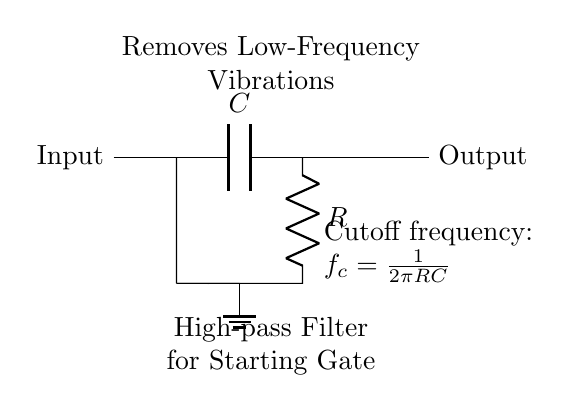What are the main components of the circuit? The main components visible in the circuit are a capacitor and a resistor, positioned in series. The capacitor is labeled as C and the resistor as R.
Answer: capacitor and resistor What is the function of the capacitor in this circuit? In a high-pass filter, the capacitor allows high-frequency signals to pass while blocking low-frequency ones. Therefore, it is essential for filtering vibrations.
Answer: blocking low frequencies What is the role of the resistor in this circuit? The resistor works in conjunction with the capacitor to set the cutoff frequency of the filter. It affects how the filter responds to different frequencies.
Answer: setting cutoff frequency What does the term "cutoff frequency" mean? The cutoff frequency indicates the frequency at which the output voltage of the filter is reduced to a specific level (typically, 3 dB down from the level of the input). It's determined by the values of R and C.
Answer: frequency where output is reduced How is the cutoff frequency calculated? The cutoff frequency is calculated using the formula \( f_c = \frac{1}{2\pi RC} \), relating the resistor and capacitor values to the frequency at which the circuit starts to filter.
Answer: one over two pi RC What type of signal is this circuit designed to handle? This circuit is specifically designed to handle signals with high frequencies, making it suitable for reducing unwanted low-frequency vibrations common in starting gates.
Answer: high-frequency signals What does the ground symbol indicate in the circuit? The ground symbol represents the reference point for the circuit, ensuring that the circuit has a common return path for currents and stabilizing the voltage levels.
Answer: reference point 